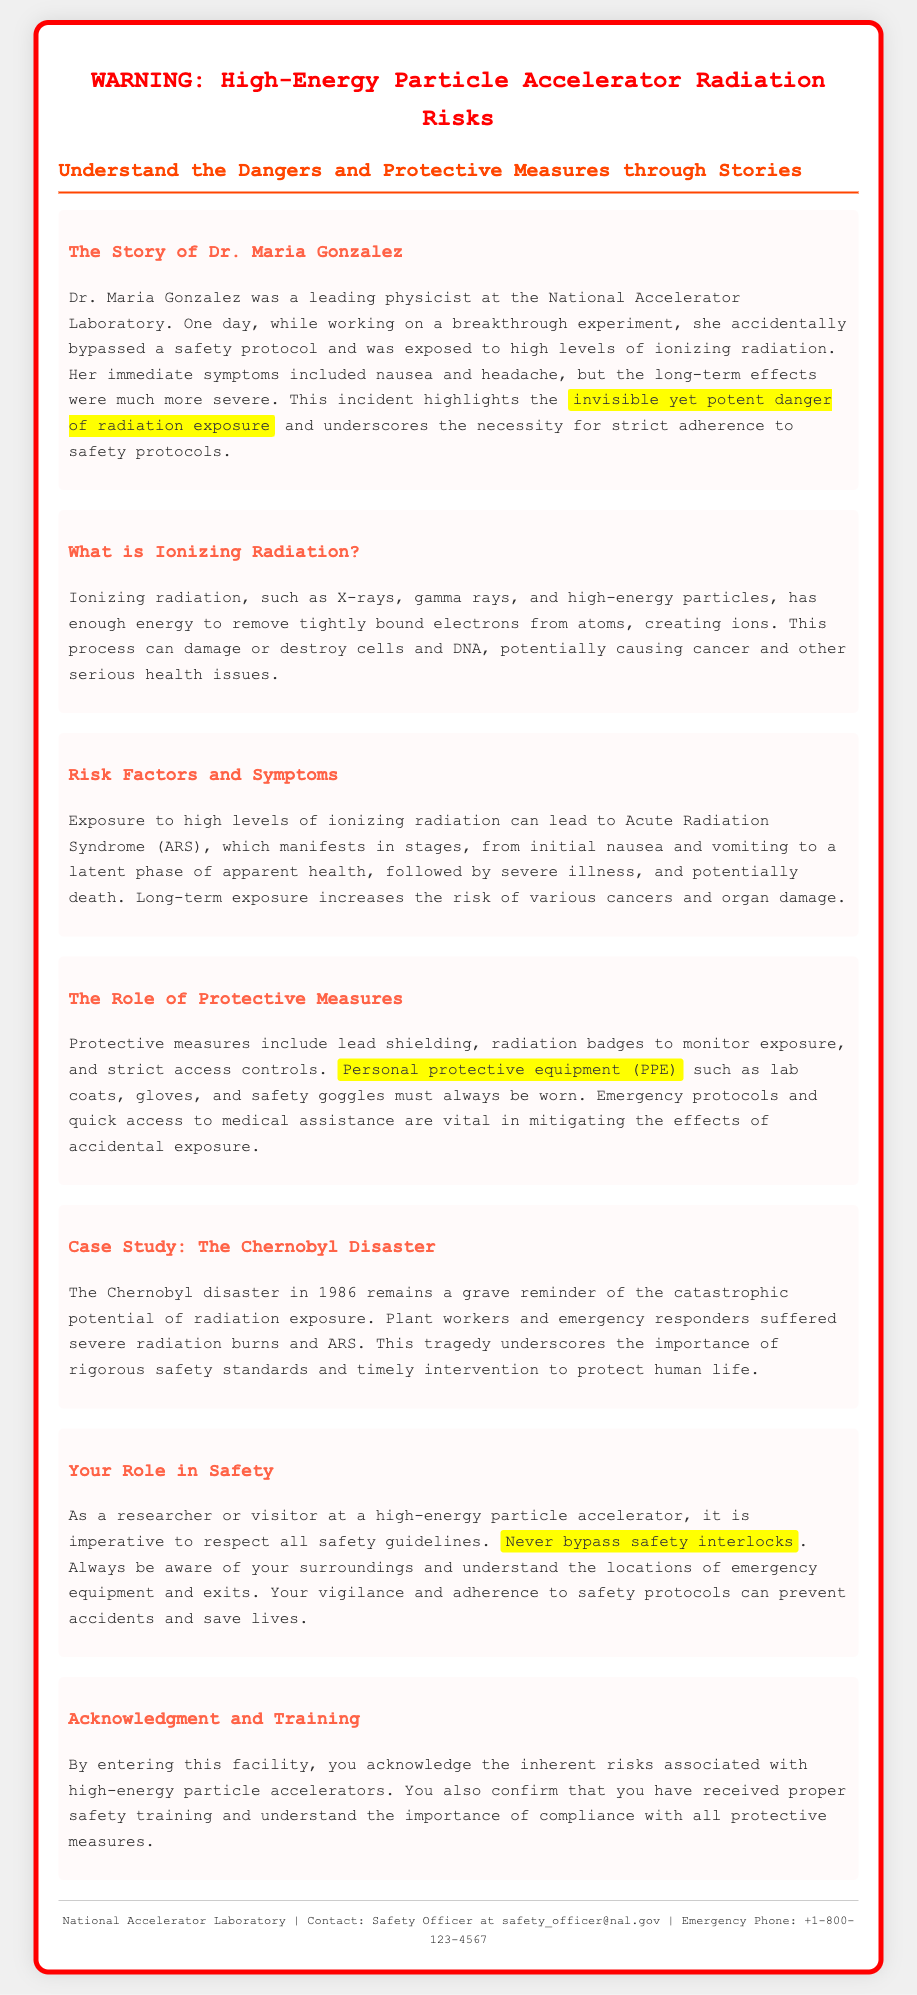What is the title of the warning document? The title of the document is stated at the top and warns about the risks associated with high-energy particle accelerators.
Answer: WARNING: High-Energy Particle Accelerator Radiation Risks Who is the main character in the story? The main character of the story that illustrates the dangers of radiation exposure is mentioned in the section about Dr. Maria Gonzalez.
Answer: Dr. Maria Gonzalez What type of radiation is discussed in the document? The document explains that ionizing radiation includes X-rays, gamma rays, and high-energy particles.
Answer: Ionizing radiation What protective equipment must always be worn? The document emphasizes the necessity of personal protective equipment in the role of safety and health at the facility.
Answer: PPE What incident is used as a case study in the document? The document refers to a significant historical event that highlights the importance of safety in the context of radiation.
Answer: The Chernobyl disaster What should you never bypass? The text warns against certain actions that may compromise safety protocols in a high-energy particle accelerator environment.
Answer: Safety interlocks What is the emergency contact phone number provided? Contact information for emergencies is listed at the bottom of the document for immediate assistance.
Answer: +1-800-123-4567 What do you acknowledge by entering the facility? The document specifies the acknowledgment required of individuals who enter the facility regarding the inherent risks involved.
Answer: Inherent risks associated with high-energy particle accelerators 